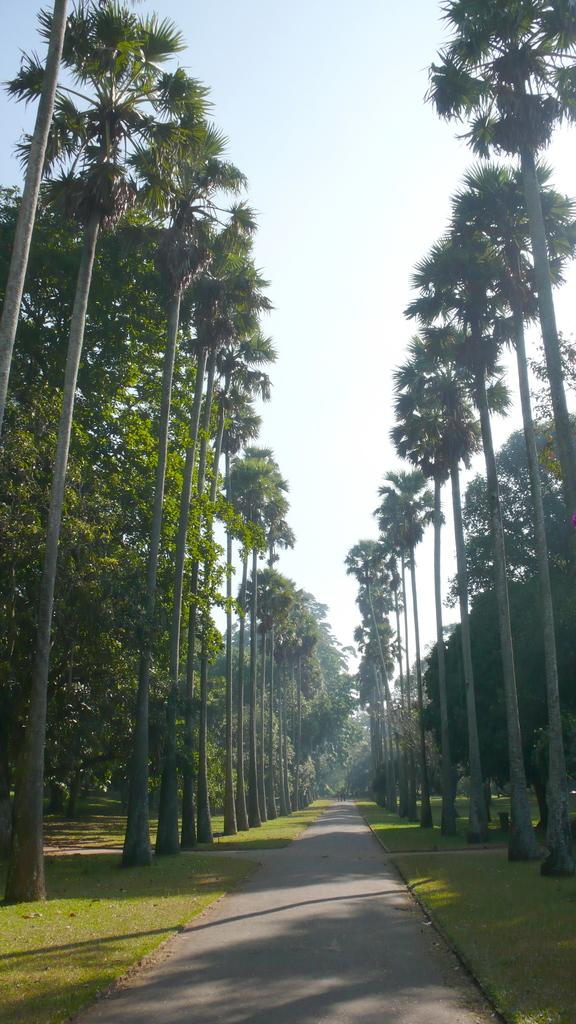What type of vegetation can be seen in the image? There are trees in the image. What is visible beneath the trees? The ground is visible in the image. What type of pathway is present in the image? There is a road in the image. What is visible above the trees and road? The sky is visible in the image. Where is the drain located in the image? There is no drain present in the image. What type of sand can be seen on the road in the image? There is no sand present on the road in the image. 